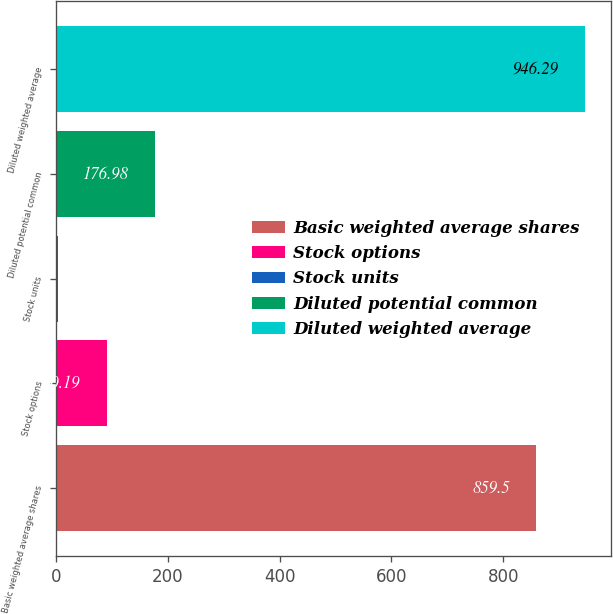<chart> <loc_0><loc_0><loc_500><loc_500><bar_chart><fcel>Basic weighted average shares<fcel>Stock options<fcel>Stock units<fcel>Diluted potential common<fcel>Diluted weighted average<nl><fcel>859.5<fcel>90.19<fcel>3.4<fcel>176.98<fcel>946.29<nl></chart> 